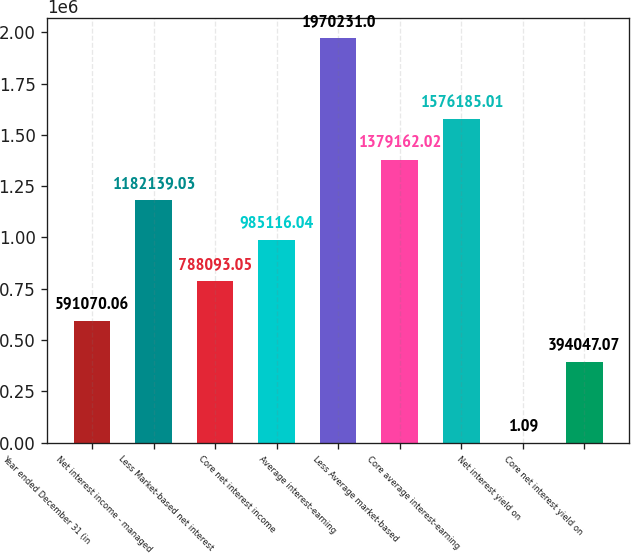Convert chart to OTSL. <chart><loc_0><loc_0><loc_500><loc_500><bar_chart><fcel>Year ended December 31 (in<fcel>Net interest income - managed<fcel>Less Market-based net interest<fcel>Core net interest income<fcel>Average interest-earning<fcel>Less Average market-based<fcel>Core average interest-earning<fcel>Net interest yield on<fcel>Core net interest yield on<nl><fcel>591070<fcel>1.18214e+06<fcel>788093<fcel>985116<fcel>1.97023e+06<fcel>1.37916e+06<fcel>1.57619e+06<fcel>1.09<fcel>394047<nl></chart> 